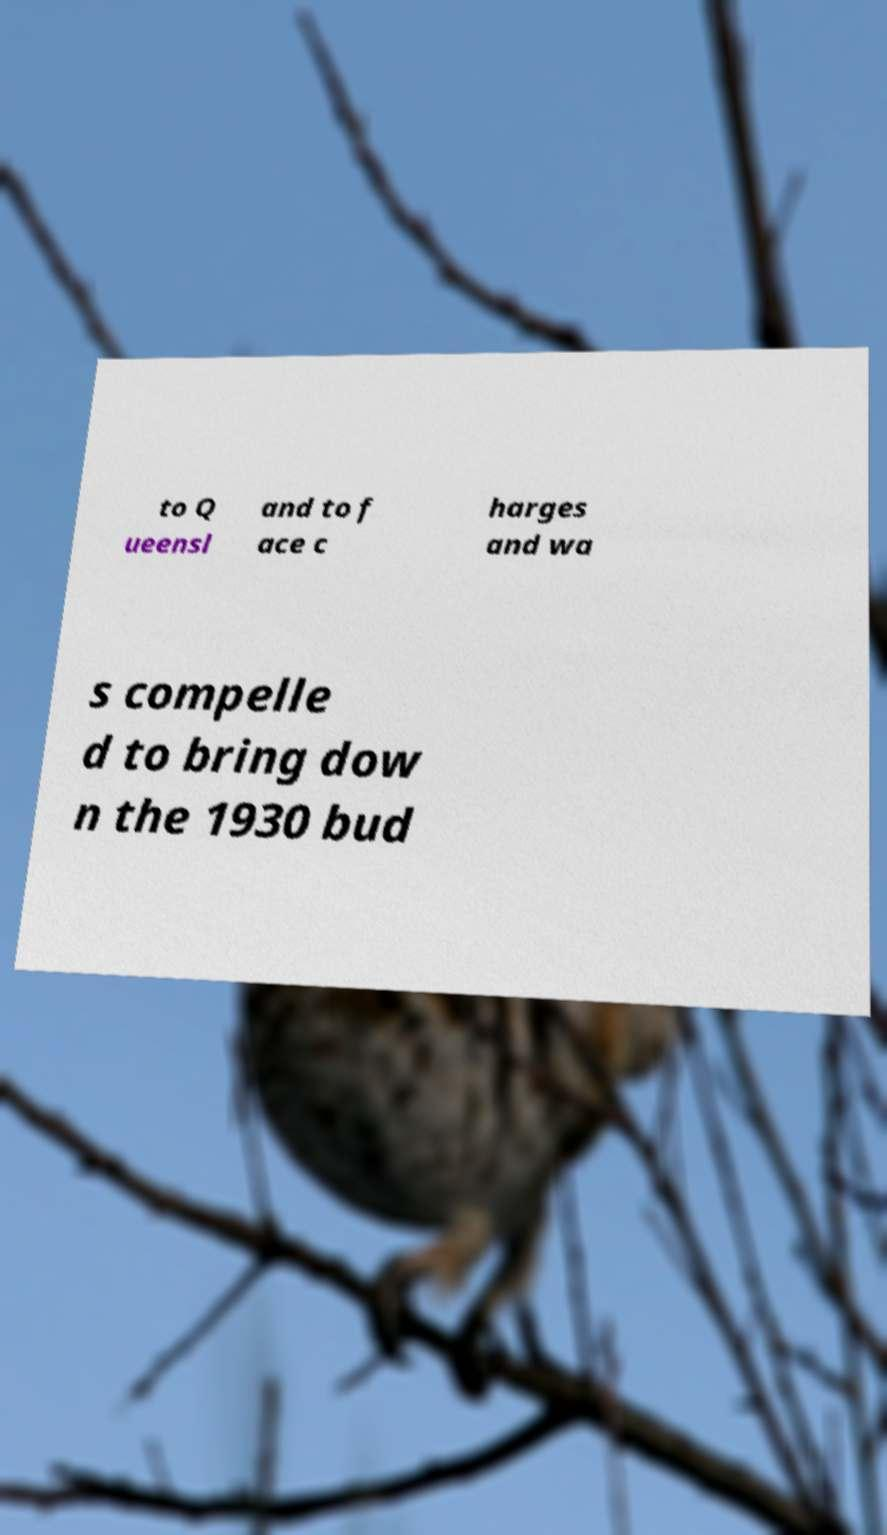Can you read and provide the text displayed in the image?This photo seems to have some interesting text. Can you extract and type it out for me? to Q ueensl and to f ace c harges and wa s compelle d to bring dow n the 1930 bud 